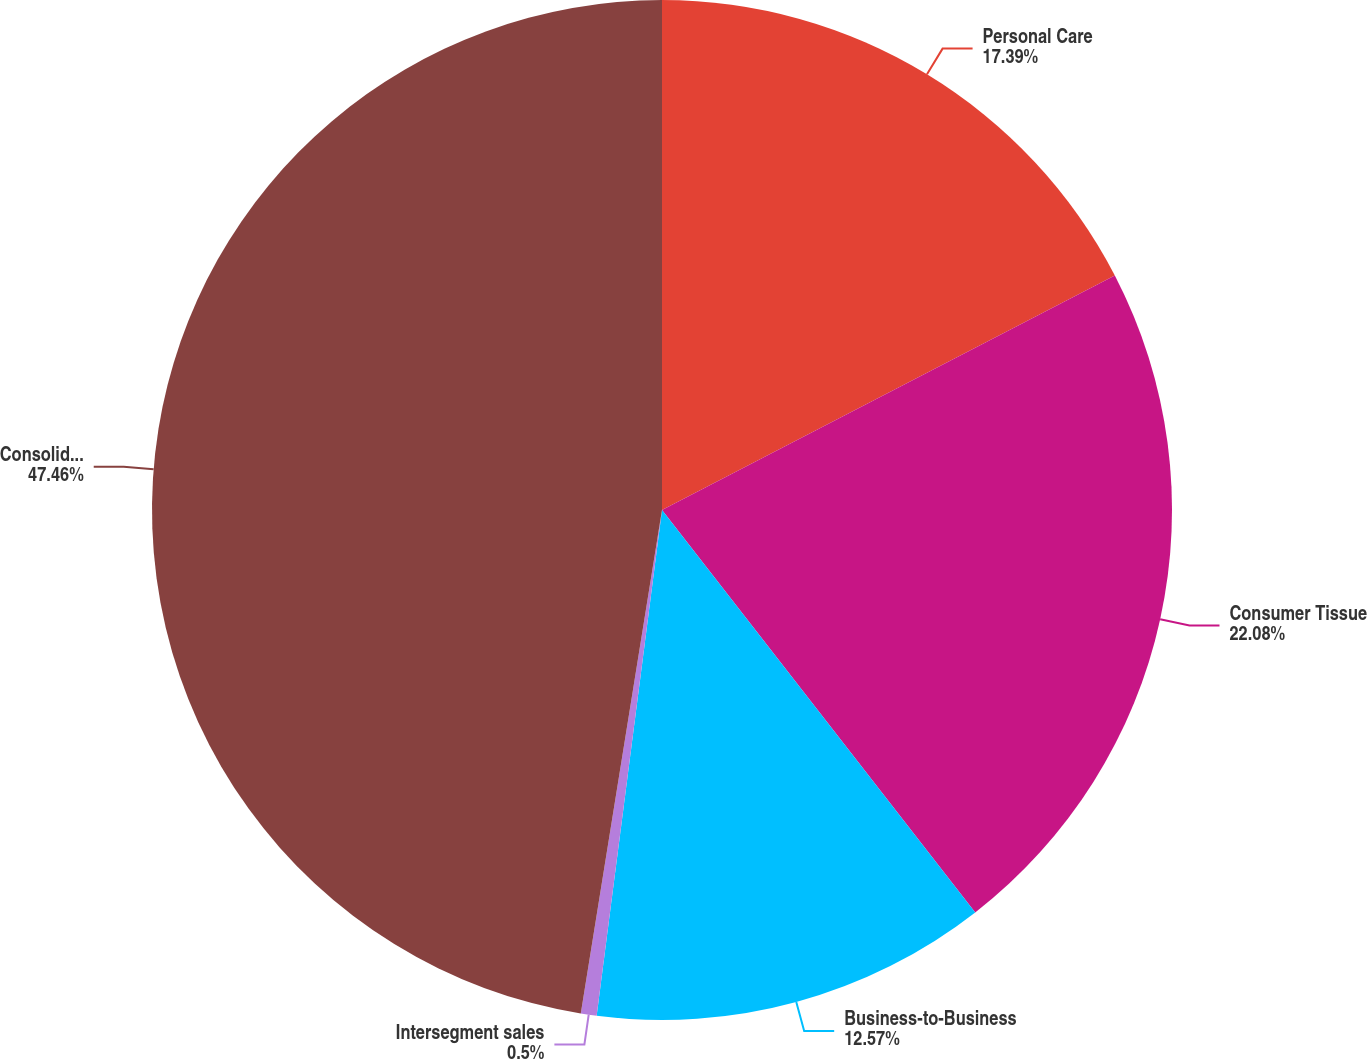Convert chart to OTSL. <chart><loc_0><loc_0><loc_500><loc_500><pie_chart><fcel>Personal Care<fcel>Consumer Tissue<fcel>Business-to-Business<fcel>Intersegment sales<fcel>Consolidated<nl><fcel>17.39%<fcel>22.08%<fcel>12.57%<fcel>0.5%<fcel>47.45%<nl></chart> 